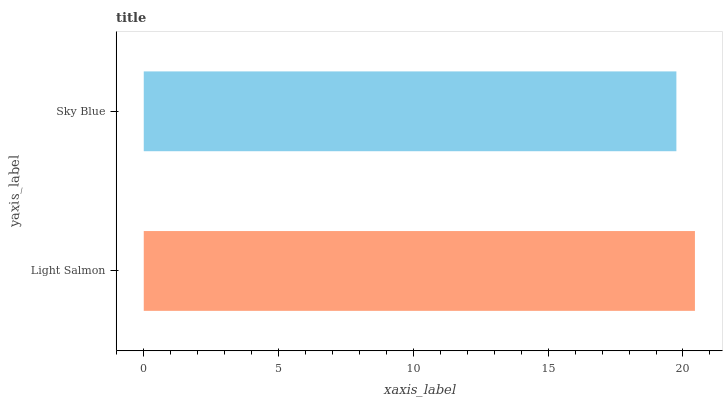Is Sky Blue the minimum?
Answer yes or no. Yes. Is Light Salmon the maximum?
Answer yes or no. Yes. Is Sky Blue the maximum?
Answer yes or no. No. Is Light Salmon greater than Sky Blue?
Answer yes or no. Yes. Is Sky Blue less than Light Salmon?
Answer yes or no. Yes. Is Sky Blue greater than Light Salmon?
Answer yes or no. No. Is Light Salmon less than Sky Blue?
Answer yes or no. No. Is Light Salmon the high median?
Answer yes or no. Yes. Is Sky Blue the low median?
Answer yes or no. Yes. Is Sky Blue the high median?
Answer yes or no. No. Is Light Salmon the low median?
Answer yes or no. No. 